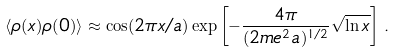Convert formula to latex. <formula><loc_0><loc_0><loc_500><loc_500>\langle \rho ( x ) \rho ( 0 ) \rangle \approx \cos ( 2 \pi x / a ) \exp \left [ - \frac { 4 \pi } { ( 2 m e ^ { 2 } a ) ^ { 1 / 2 } } \sqrt { \ln x } \right ] \, .</formula> 